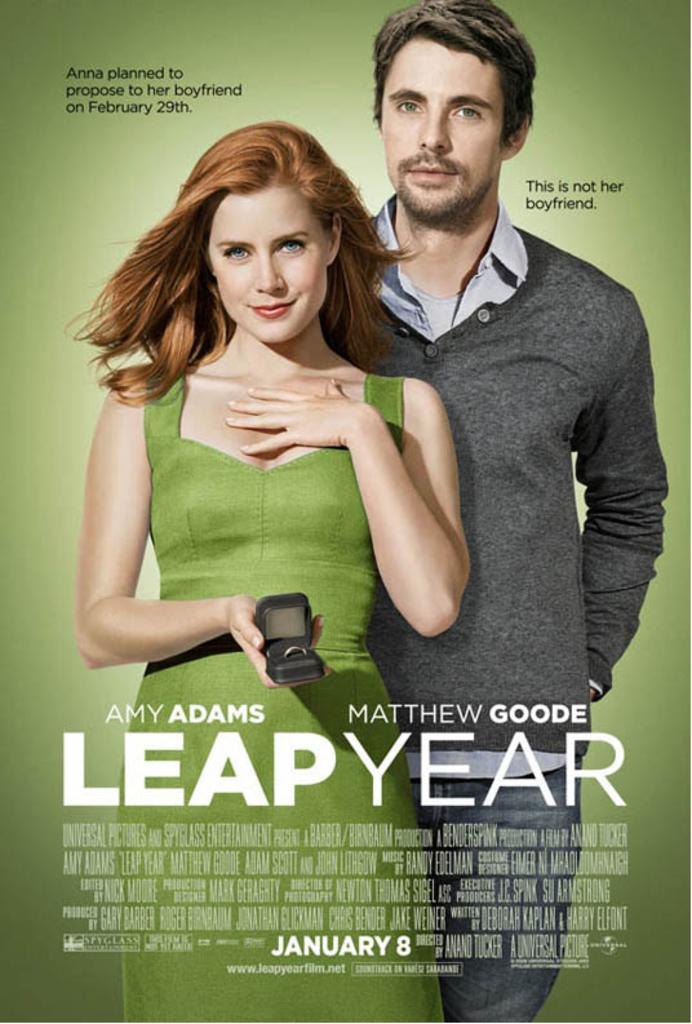Please provide a concise description of this image. In this image I can see two persons standing. The person at left is wearing green color dress and holding some object, the person at right is wearing green color shirt and I can see something is written on the image and the background is in green color. 